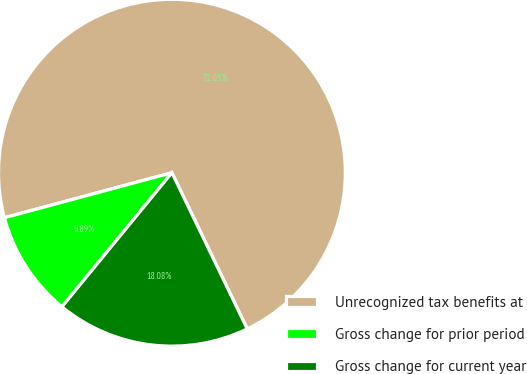<chart> <loc_0><loc_0><loc_500><loc_500><pie_chart><fcel>Unrecognized tax benefits at<fcel>Gross change for prior period<fcel>Gross change for current year<nl><fcel>72.03%<fcel>9.89%<fcel>18.08%<nl></chart> 